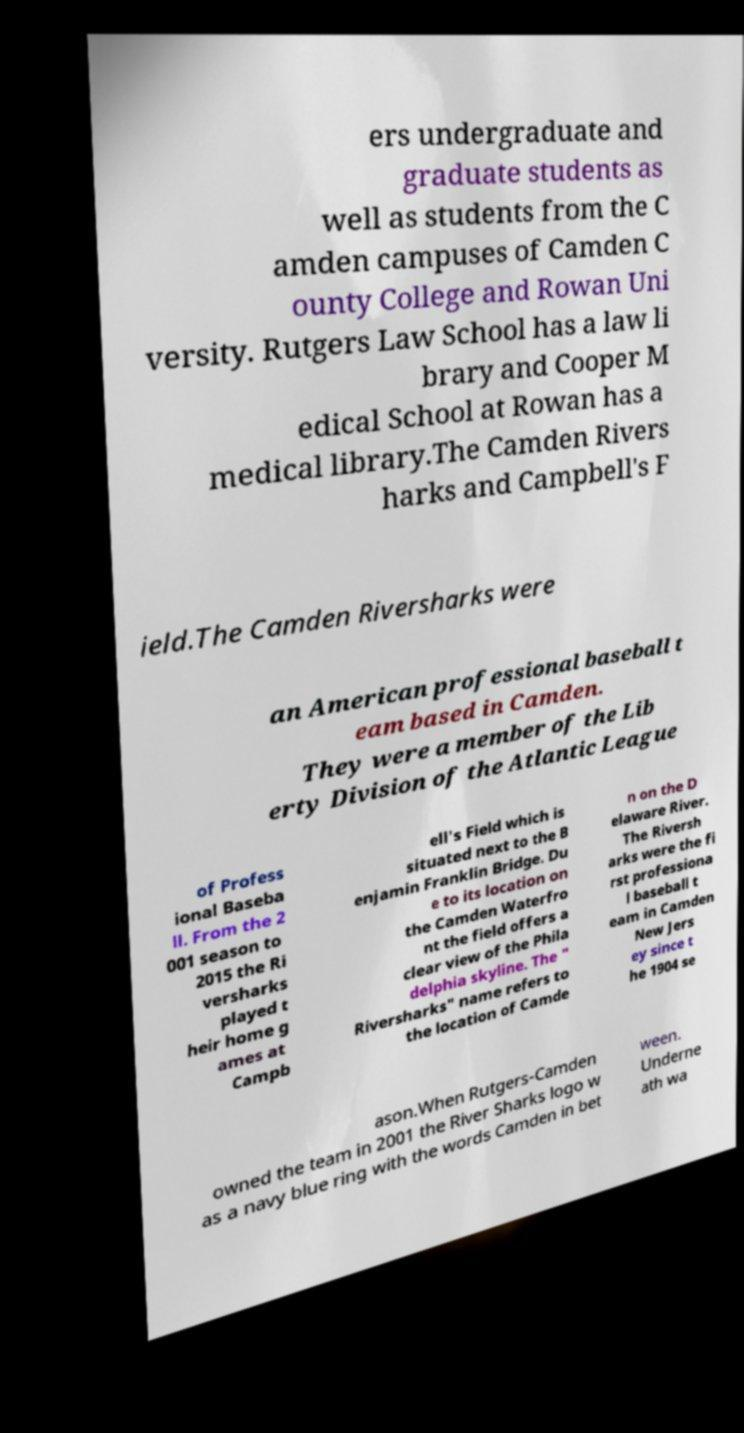Could you assist in decoding the text presented in this image and type it out clearly? ers undergraduate and graduate students as well as students from the C amden campuses of Camden C ounty College and Rowan Uni versity. Rutgers Law School has a law li brary and Cooper M edical School at Rowan has a medical library.The Camden Rivers harks and Campbell's F ield.The Camden Riversharks were an American professional baseball t eam based in Camden. They were a member of the Lib erty Division of the Atlantic League of Profess ional Baseba ll. From the 2 001 season to 2015 the Ri versharks played t heir home g ames at Campb ell's Field which is situated next to the B enjamin Franklin Bridge. Du e to its location on the Camden Waterfro nt the field offers a clear view of the Phila delphia skyline. The " Riversharks" name refers to the location of Camde n on the D elaware River. The Riversh arks were the fi rst professiona l baseball t eam in Camden New Jers ey since t he 1904 se ason.When Rutgers-Camden owned the team in 2001 the River Sharks logo w as a navy blue ring with the words Camden in bet ween. Underne ath wa 